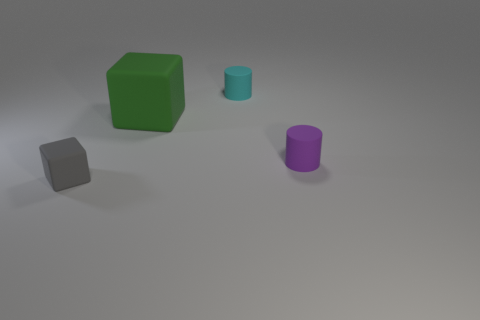Add 1 gray rubber blocks. How many objects exist? 5 Add 2 rubber things. How many rubber things are left? 6 Add 2 small blue spheres. How many small blue spheres exist? 2 Subtract 0 brown cylinders. How many objects are left? 4 Subtract all matte blocks. Subtract all big green things. How many objects are left? 1 